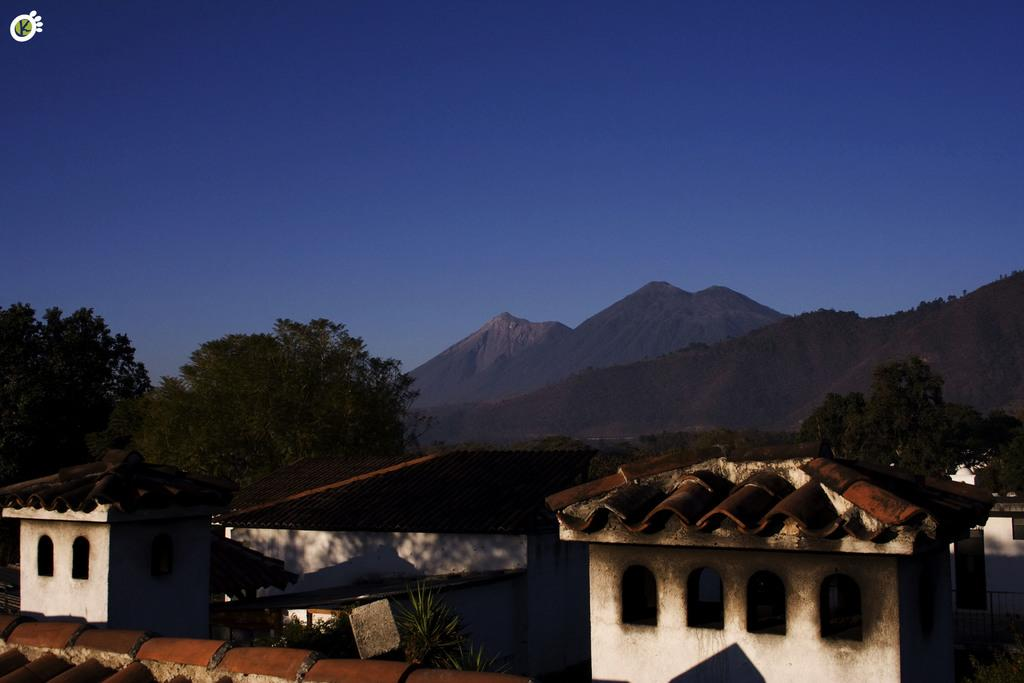What type of structures are present in the image? There are houses in the image. What can be seen in front of the houses? There are trees in front of the houses. What natural feature is visible in the distance? There are mountains visible in the image. What is visible above the houses and trees? The sky is visible in the image. What type of basket is being used to catch the waves in the image? There are no baskets or waves present in the image. 